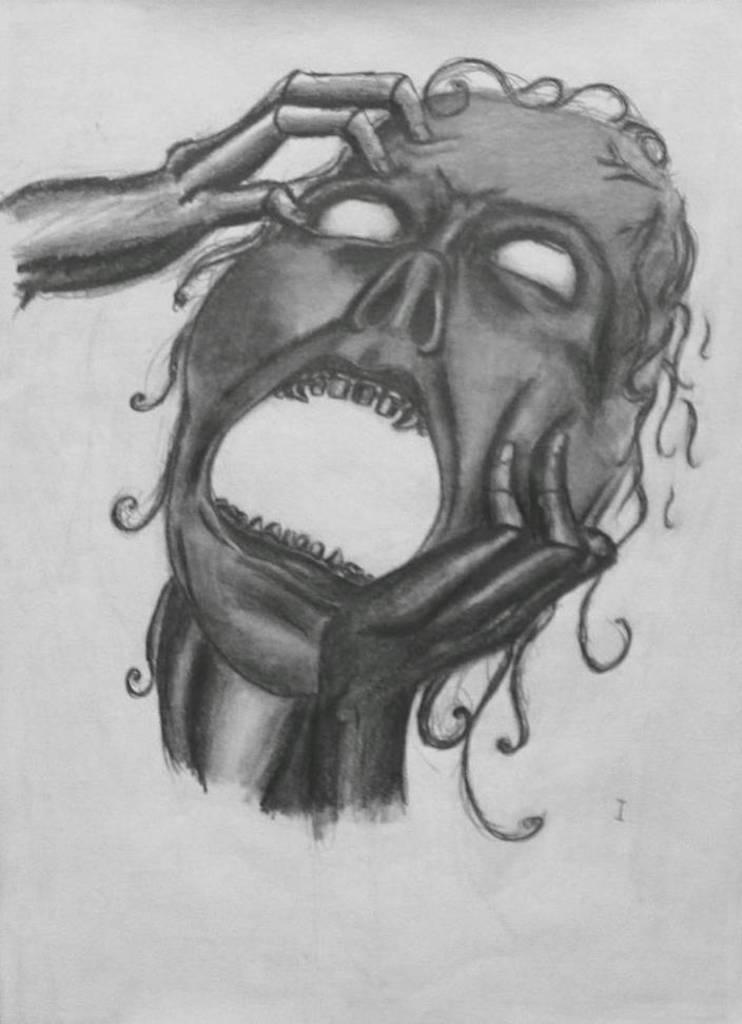Describe this image in one or two sentences. In this image, we can see a human drawing on the white surface. 